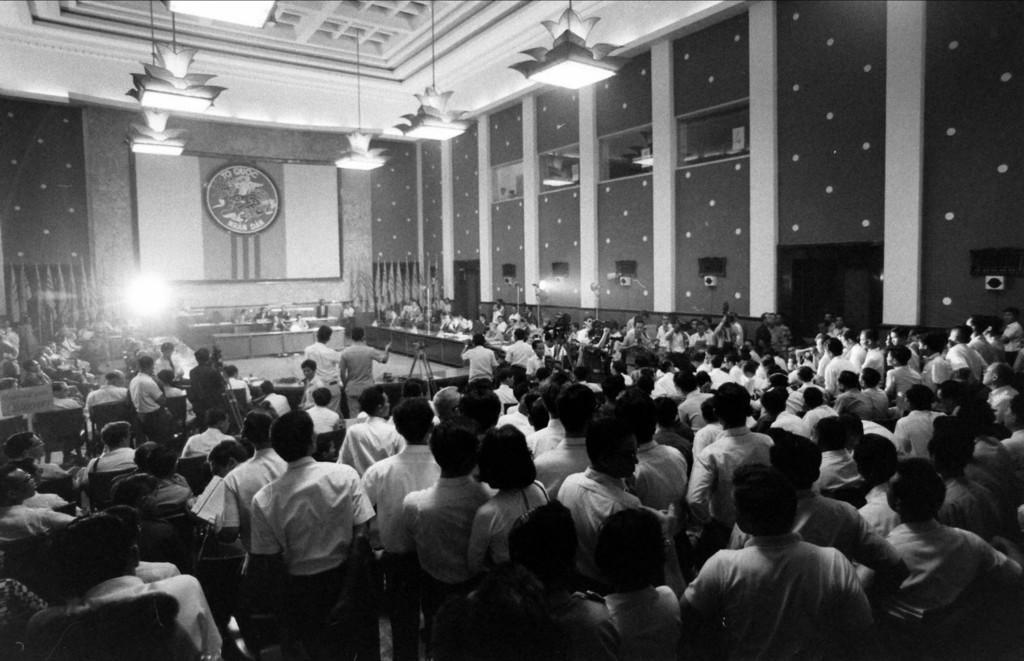What are the people in the image doing? There are people standing and sitting in the image. What architectural features can be seen in the image? Pillars are visible in the image. What type of lighting is present in the image? Hanging lights are present in the image. What part of the room is visible in the image? The ceiling is visible in the image. What is used for amplifying sound in the image? Speakers are present in the image. Where is the sister of the person sitting in the image? There is no mention of a sister in the image, so it cannot be determined where she might be. 